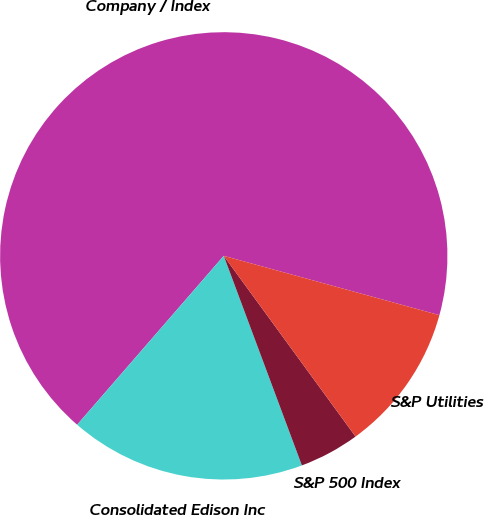Convert chart to OTSL. <chart><loc_0><loc_0><loc_500><loc_500><pie_chart><fcel>Company / Index<fcel>Consolidated Edison Inc<fcel>S&P 500 Index<fcel>S&P Utilities<nl><fcel>67.9%<fcel>17.06%<fcel>4.35%<fcel>10.7%<nl></chart> 